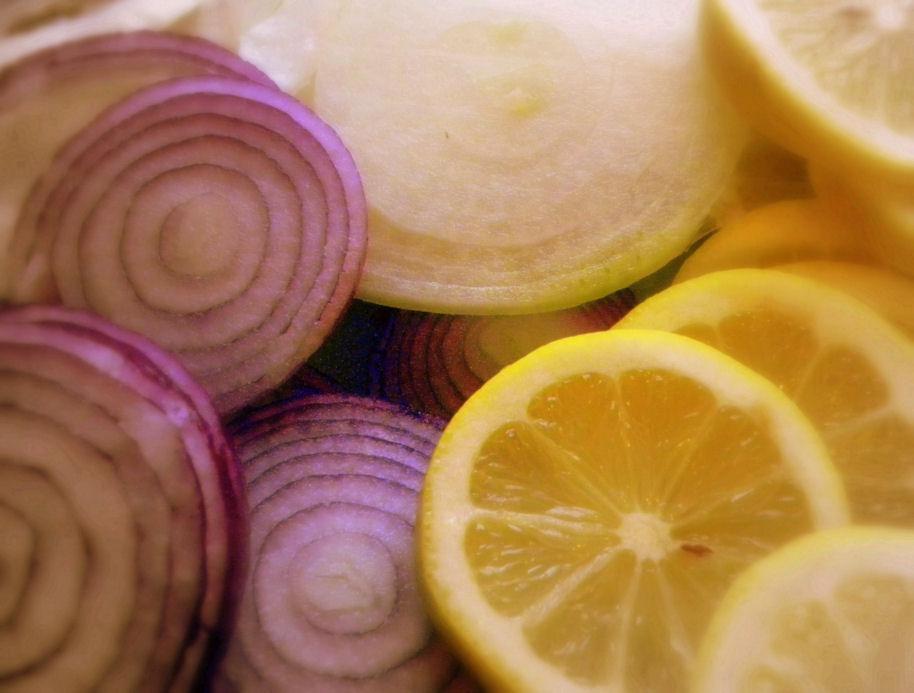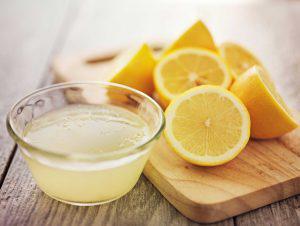The first image is the image on the left, the second image is the image on the right. Analyze the images presented: Is the assertion "In one image, half a lemon, onions and some garlic are on a square mat." valid? Answer yes or no. No. The first image is the image on the left, the second image is the image on the right. Considering the images on both sides, is "One picture has atleast 2 full cloves of garlic and 2 full onions" valid? Answer yes or no. No. 